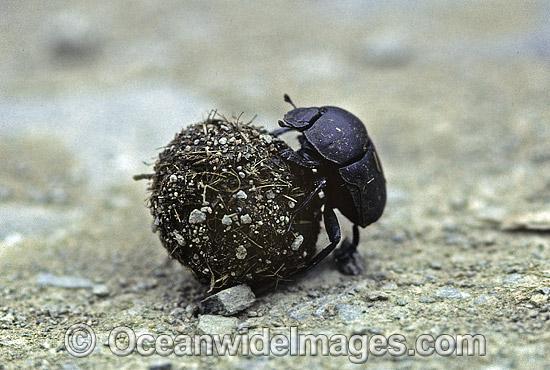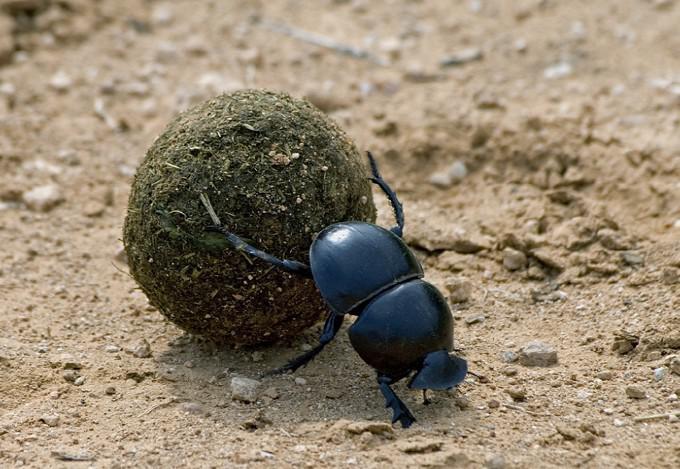The first image is the image on the left, the second image is the image on the right. Evaluate the accuracy of this statement regarding the images: "There are two beetles near a clod of dirt in one of the images.". Is it true? Answer yes or no. No. The first image is the image on the left, the second image is the image on the right. Examine the images to the left and right. Is the description "An image includes two beetles, with at least one beetle in contact with a round dungball." accurate? Answer yes or no. No. 